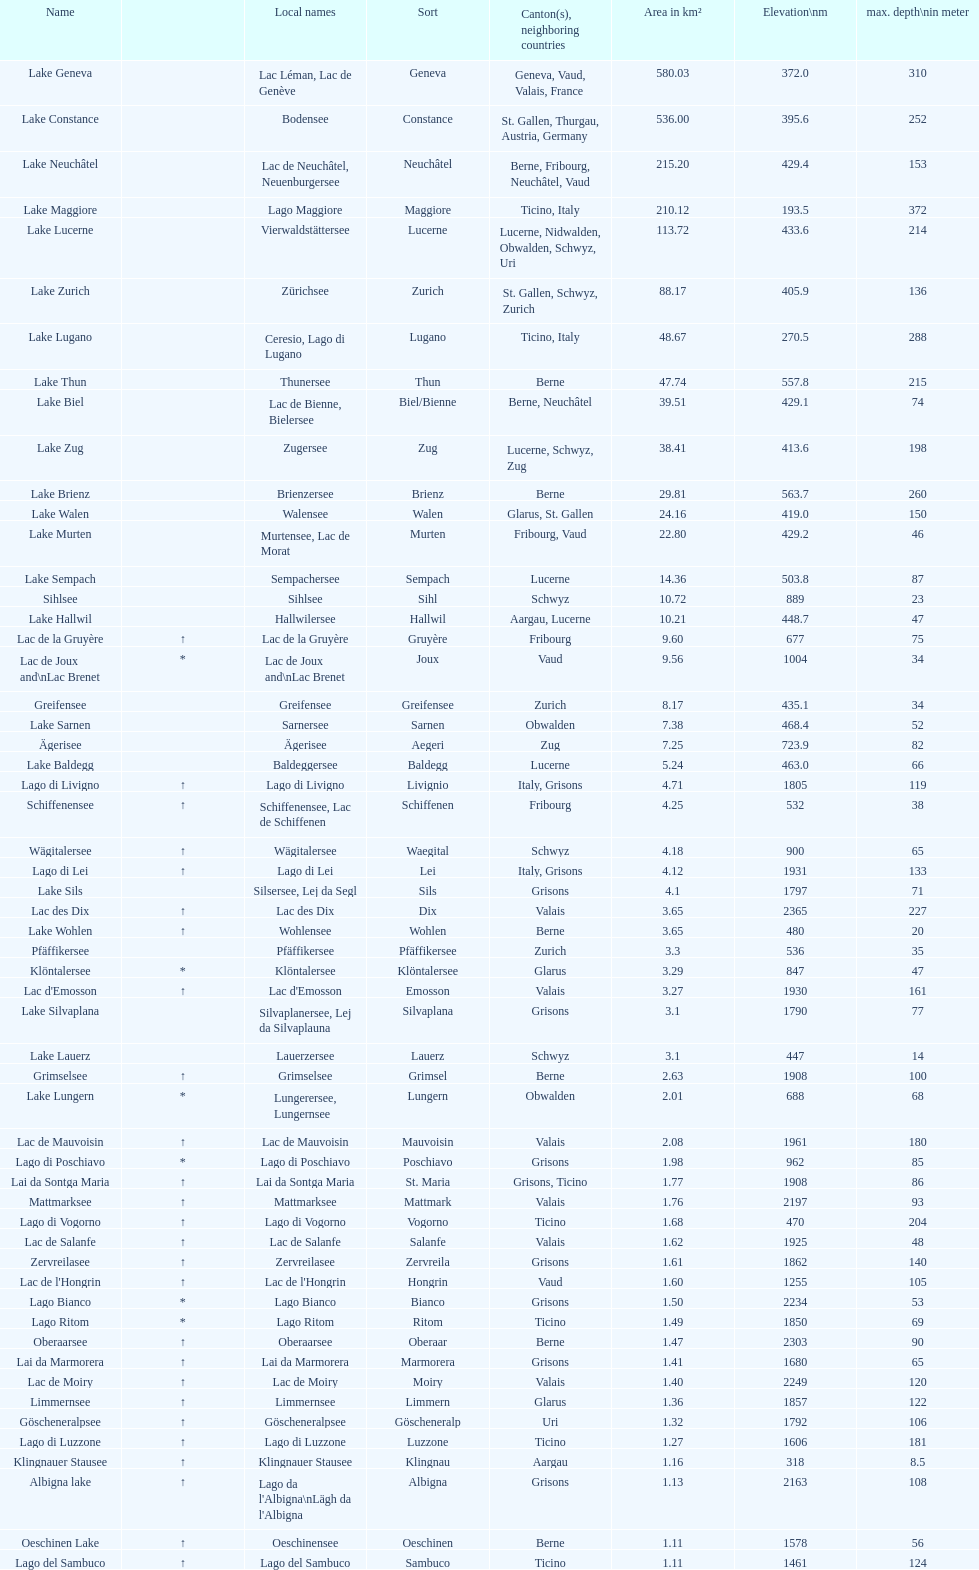What's the total max depth of lake geneva and lake constance combined? 562. 